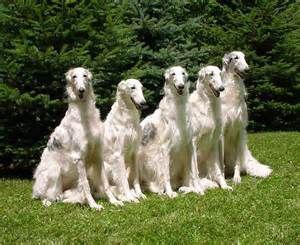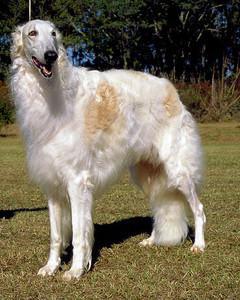The first image is the image on the left, the second image is the image on the right. Assess this claim about the two images: "At least three white dogs are shown.". Correct or not? Answer yes or no. Yes. The first image is the image on the left, the second image is the image on the right. Considering the images on both sides, is "There are more than two dogs." valid? Answer yes or no. Yes. 